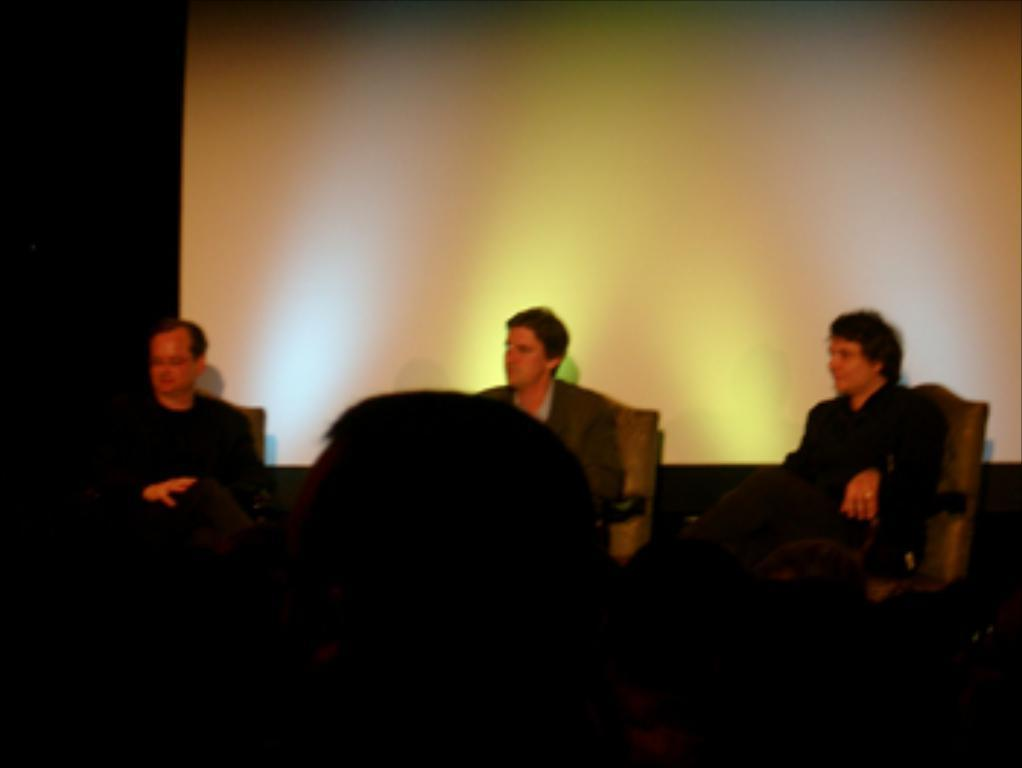What are the people in the image doing? The people in the image are sitting on chairs. What can be seen in the background of the image? There is a screen visible in the background of the image. What type of lead is being used by the people in the image? There is no lead present in the image; the people are sitting on chairs. 